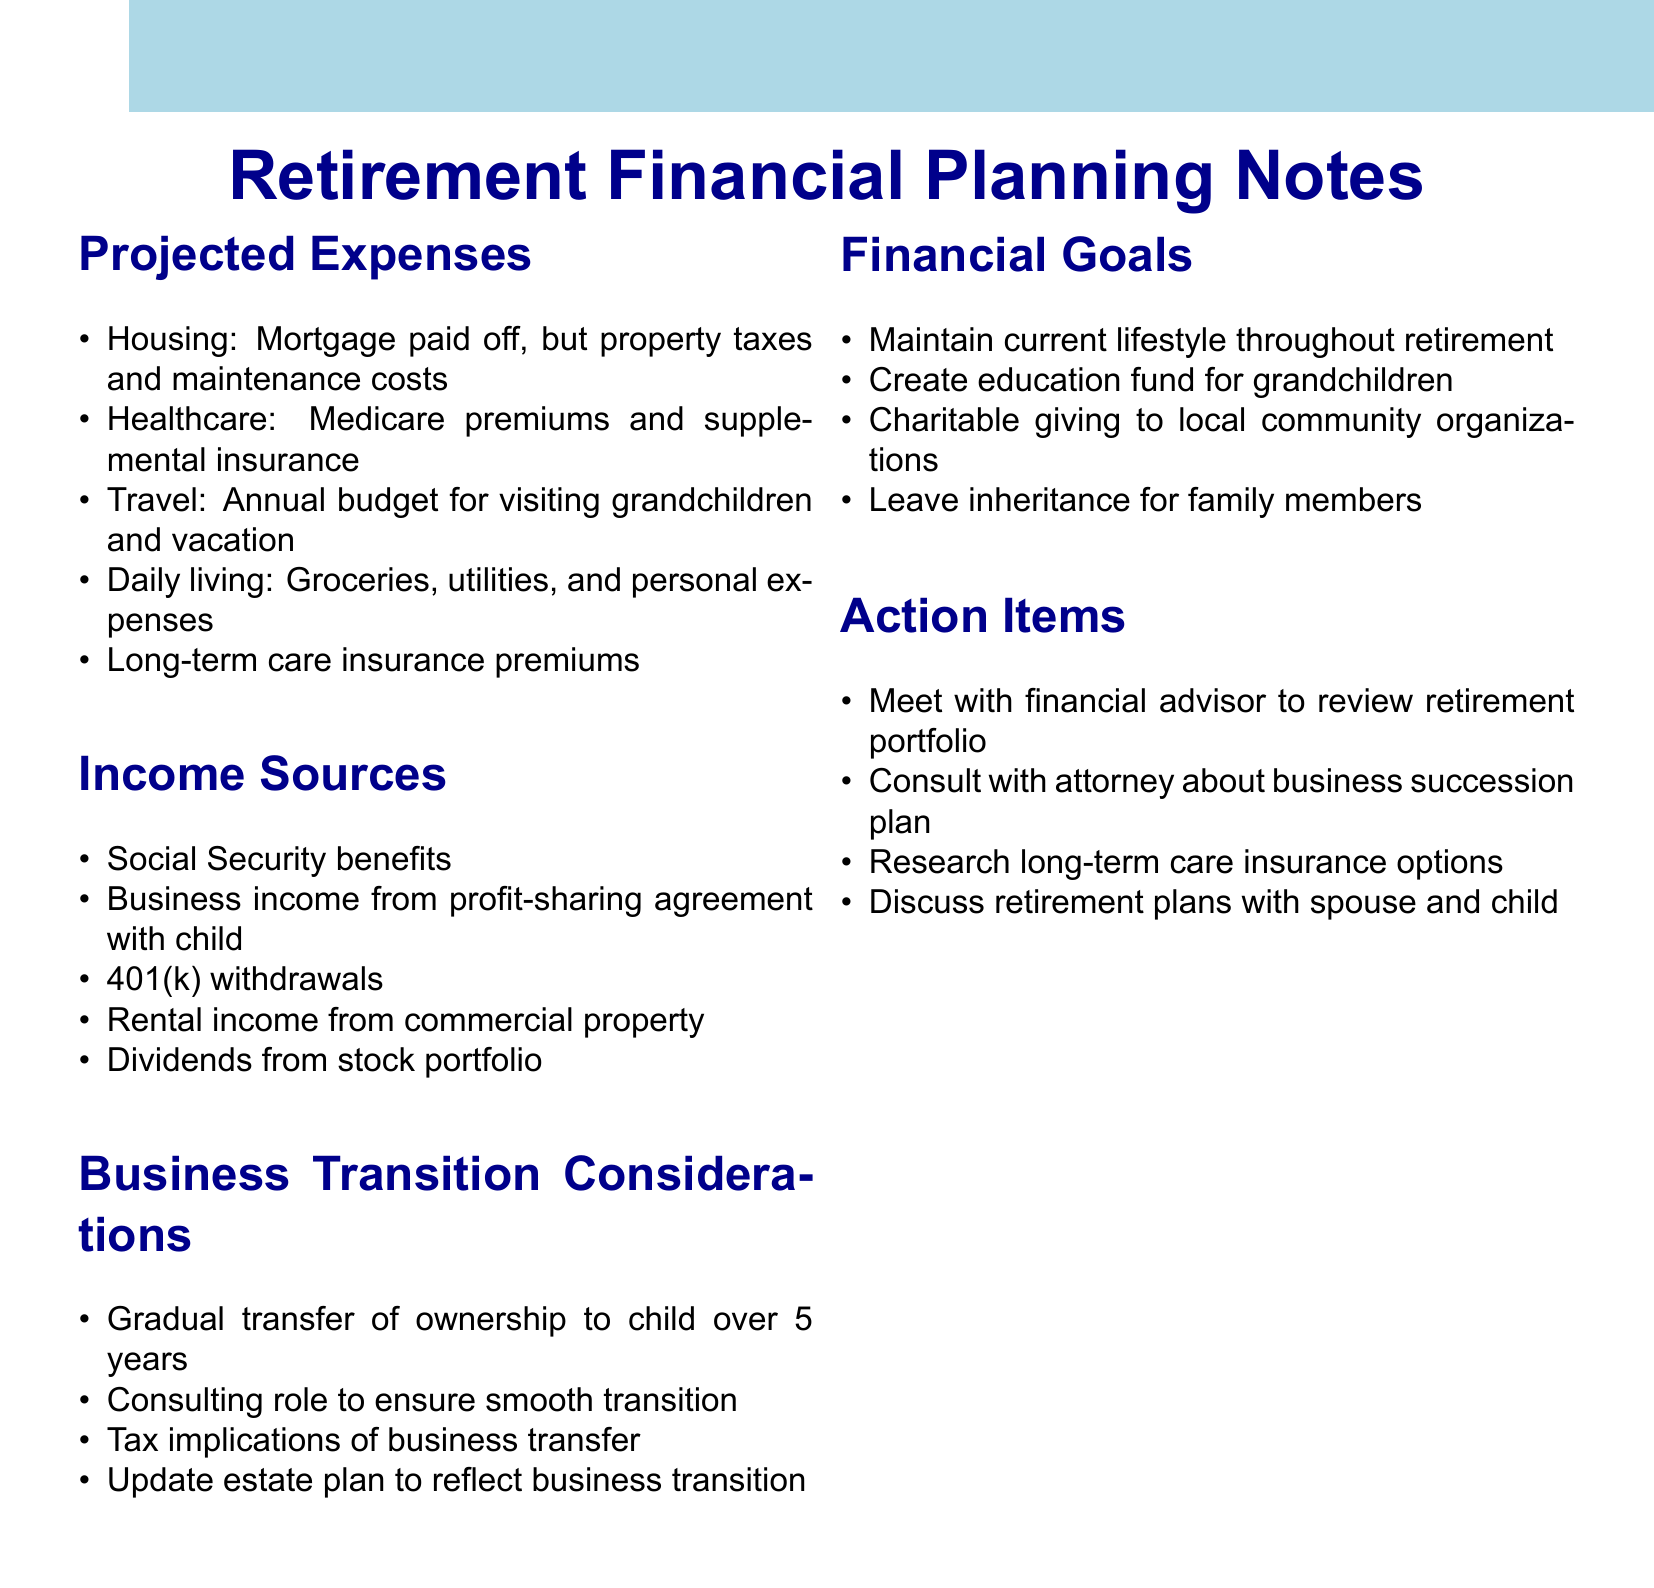what are the projected expenses related to healthcare? The document lists Medicare premiums and supplemental insurance under healthcare expenses.
Answer: Medicare premiums and supplemental insurance what is one source of income after retirement? One source of income mentioned in the document is Social Security benefits.
Answer: Social Security benefits how long is the planned gradual transfer of business ownership? The document states that the transfer of ownership to the child will take place over 5 years.
Answer: 5 years what is one of the financial goals outlined in the document? The document mentions maintaining the current lifestyle throughout retirement as one of the financial goals.
Answer: Maintain current lifestyle throughout retirement what action item involves consulting with professionals? The document states the action item to consult with an attorney about the business succession plan.
Answer: Consult with attorney about business succession plan how many items are listed under the income sources section? The document lists five different income sources.
Answer: 5 what is mentioned as an expense under housing? The document specifies property taxes and maintenance costs in the housing expenses section.
Answer: Property taxes and maintenance costs what long-term care option should be researched according to action items? The document suggests researching long-term care insurance options as an action item.
Answer: Long-term care insurance options which aspect of business transition is highlighted for tax implications? The document notes the tax implications of business transfer as an important consideration.
Answer: Tax implications of business transfer 